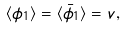Convert formula to latex. <formula><loc_0><loc_0><loc_500><loc_500>\langle \phi _ { 1 } \rangle = \langle \bar { \phi } _ { 1 } \rangle = v ,</formula> 